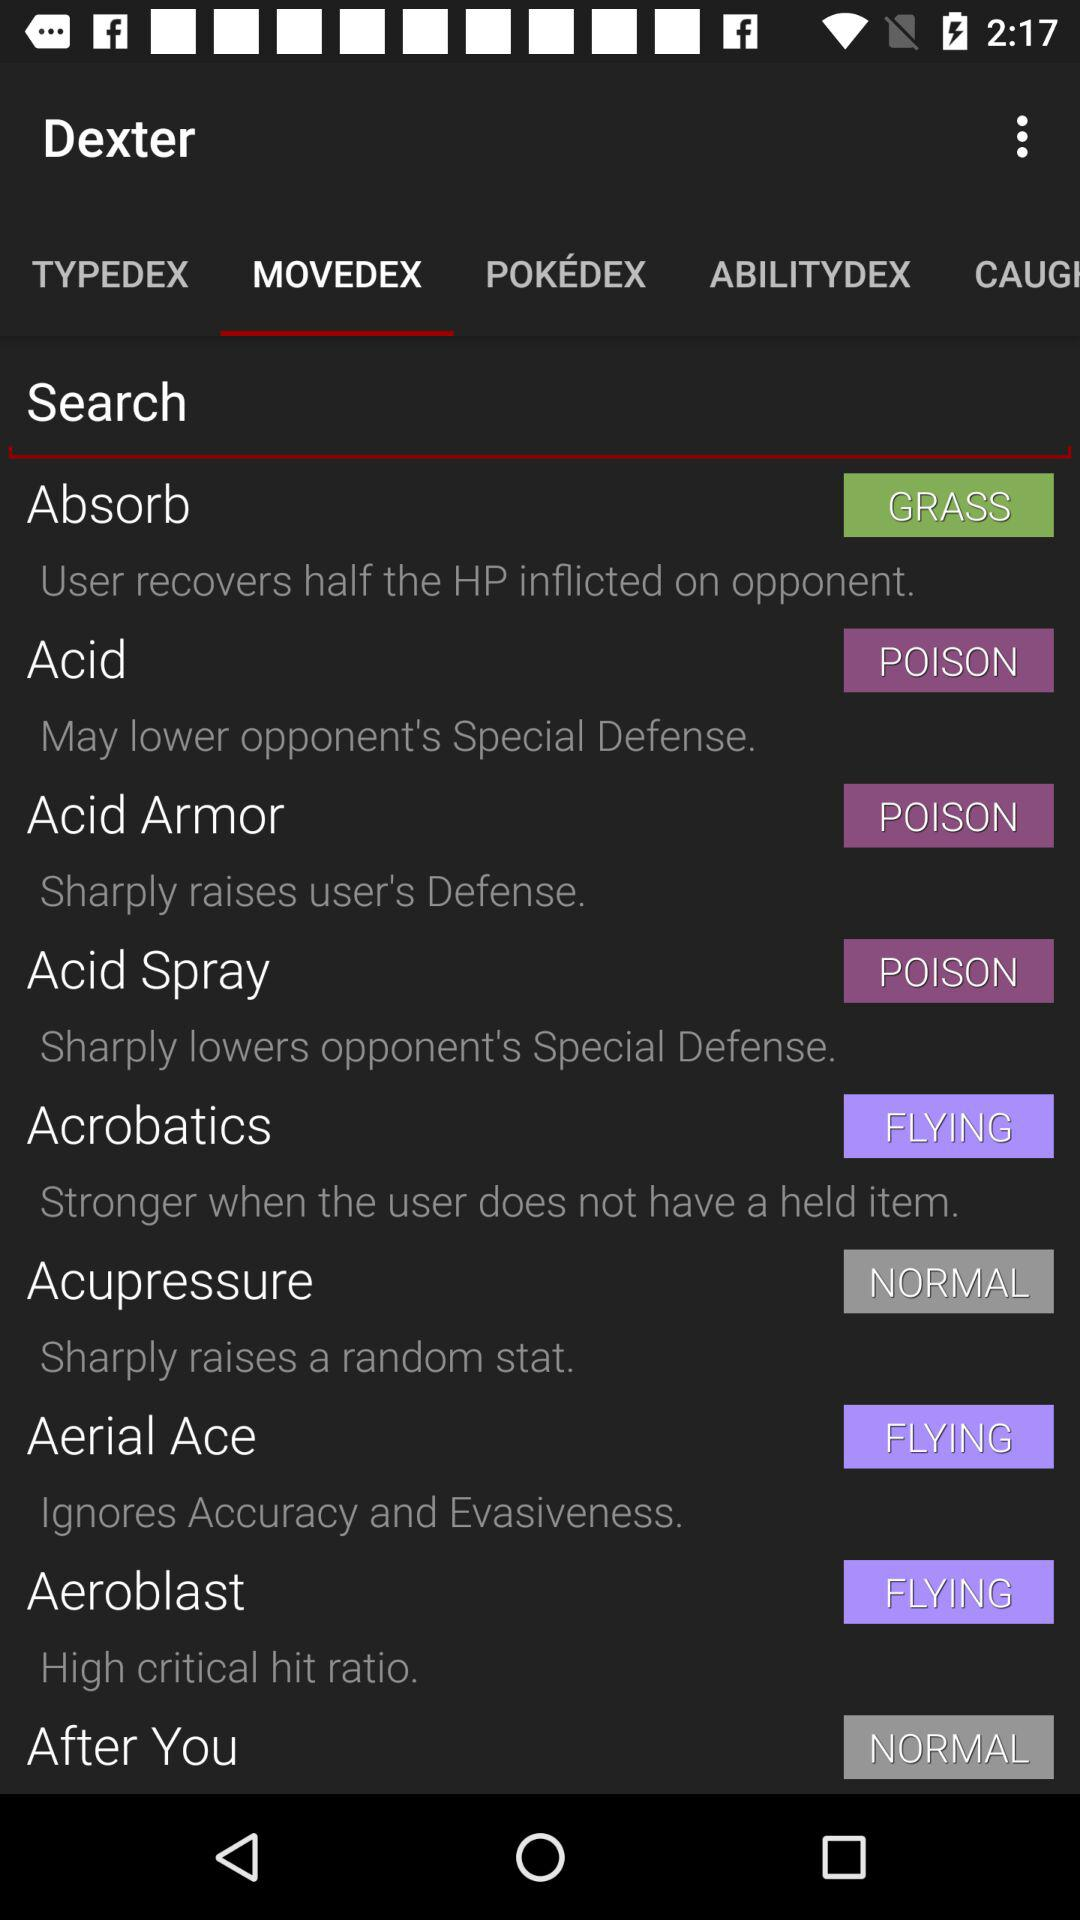What is the selected option? The selected option is "MOVEDEX". 